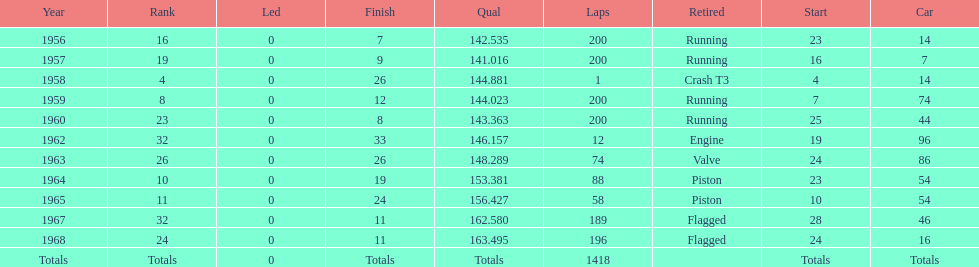What year did he have the same number car as 1964? 1965. 